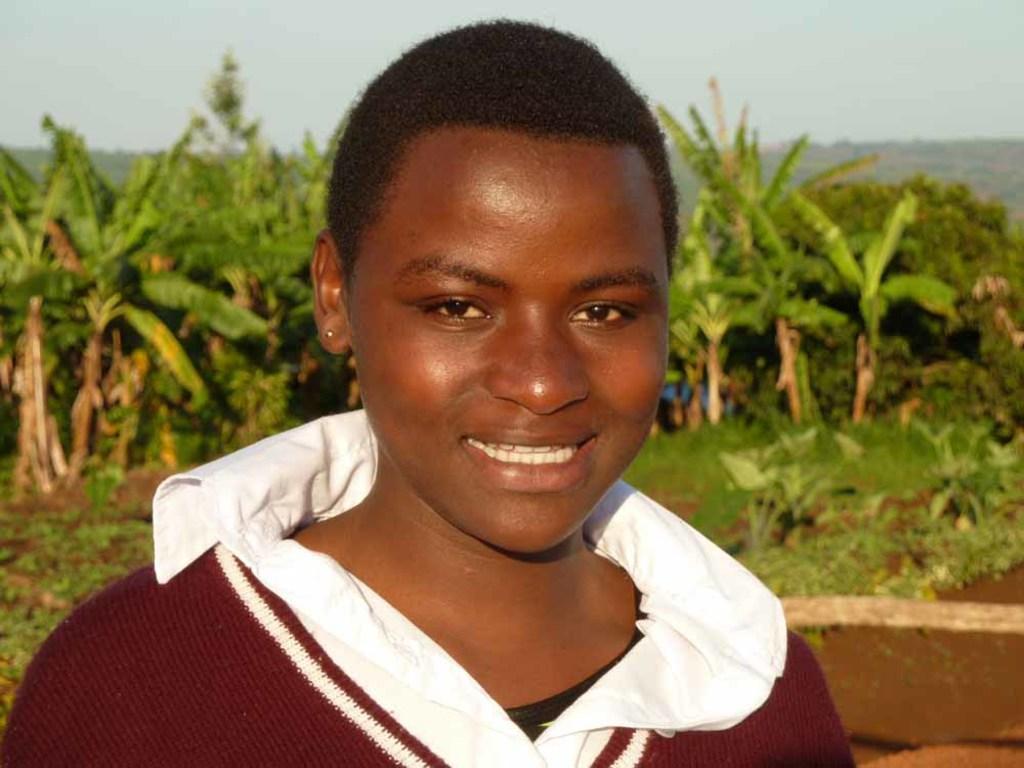In one or two sentences, can you explain what this image depicts? In the image there is a person in the foreground and the person is smiling, behind the person there are many plants. 